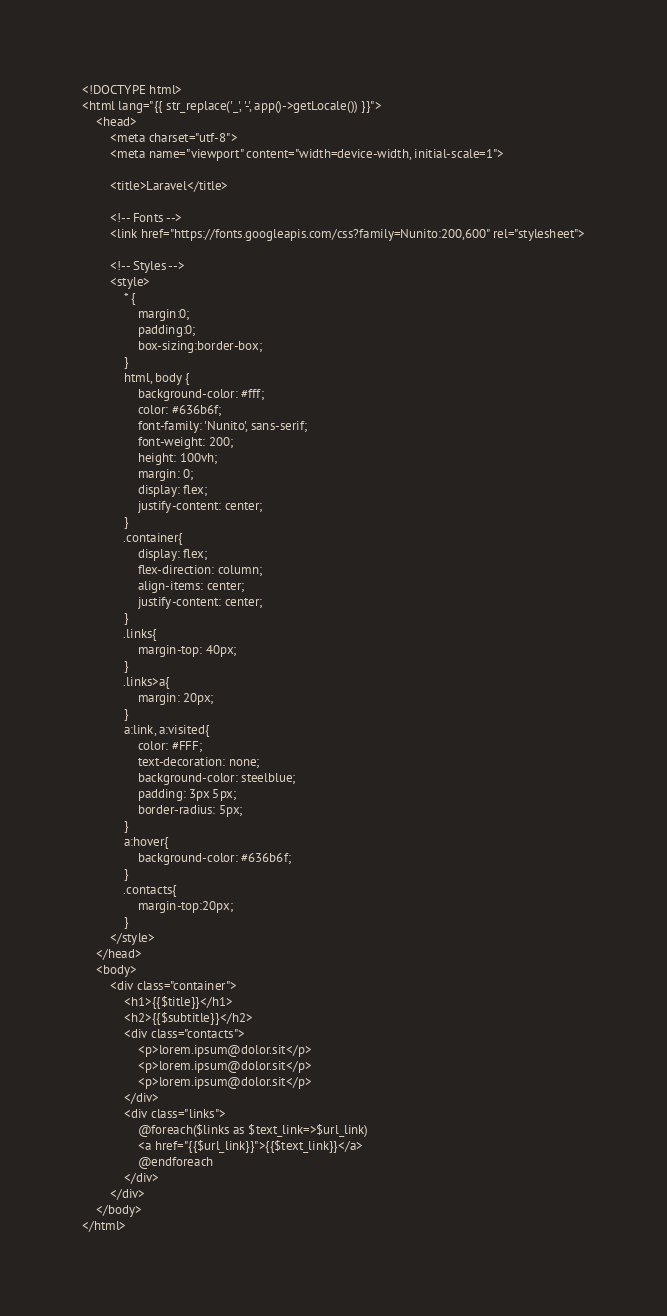<code> <loc_0><loc_0><loc_500><loc_500><_PHP_><!DOCTYPE html>
<html lang="{{ str_replace('_', '-', app()->getLocale()) }}">
    <head>
        <meta charset="utf-8">
        <meta name="viewport" content="width=device-width, initial-scale=1">

        <title>Laravel</title>

        <!-- Fonts -->
        <link href="https://fonts.googleapis.com/css?family=Nunito:200,600" rel="stylesheet">

        <!-- Styles -->
        <style>
            * {
                margin:0;
                padding:0;
                box-sizing:border-box;
            }
            html, body {
                background-color: #fff;
                color: #636b6f;
                font-family: 'Nunito', sans-serif;
                font-weight: 200;
                height: 100vh;
                margin: 0;
                display: flex;
                justify-content: center;
            }
            .container{
                display: flex;
                flex-direction: column;
                align-items: center;
                justify-content: center;
            }
            .links{
                margin-top: 40px;
            }
            .links>a{
                margin: 20px;
            }
            a:link, a:visited{
                color: #FFF;
                text-decoration: none;
                background-color: steelblue;
                padding: 3px 5px;
                border-radius: 5px;
            }
            a:hover{
                background-color: #636b6f;
            }
            .contacts{
                margin-top:20px;
            }
        </style>
    </head>
    <body>
        <div class="container">
            <h1>{{$title}}</h1>
            <h2>{{$subtitle}}</h2>
            <div class="contacts">
                <p>lorem.ipsum@dolor.sit</p>
                <p>lorem.ipsum@dolor.sit</p>
                <p>lorem.ipsum@dolor.sit</p>
            </div>
            <div class="links">
                @foreach($links as $text_link=>$url_link)
                <a href="{{$url_link}}">{{$text_link}}</a>
                @endforeach
            </div>
        </div>
    </body>
</html>
</code> 